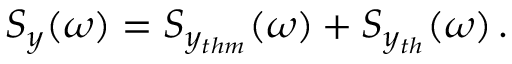<formula> <loc_0><loc_0><loc_500><loc_500>S _ { y } ( \omega ) = S _ { y _ { t h m } } ( \omega ) + S _ { y _ { t h } } ( \omega ) \, .</formula> 